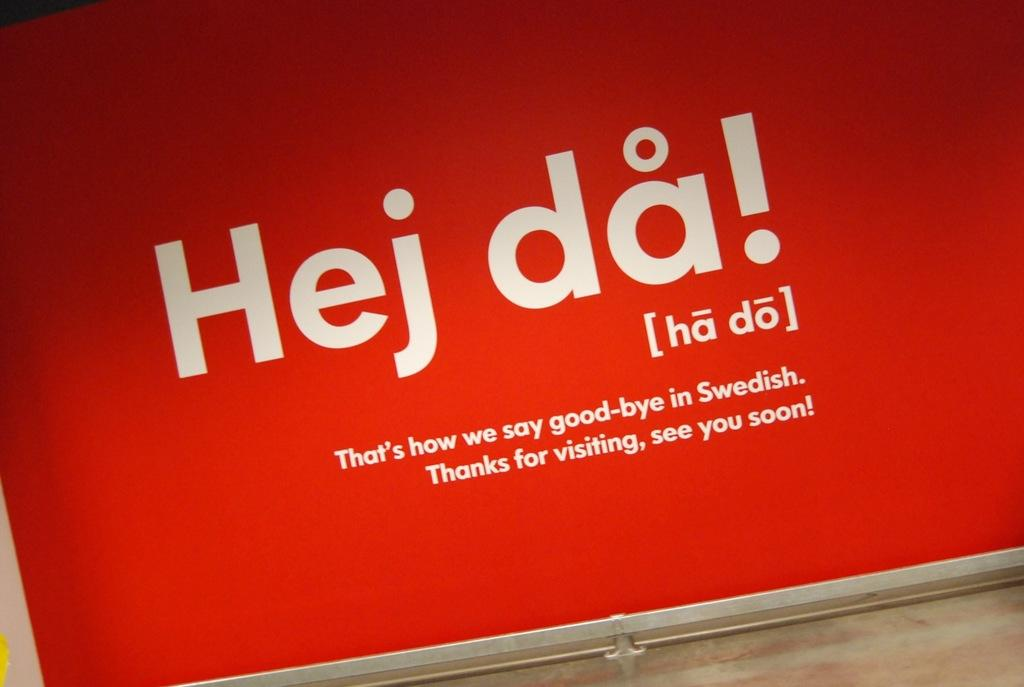<image>
Provide a brief description of the given image. A red and white sign says good-bye in Swedish. 